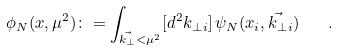Convert formula to latex. <formula><loc_0><loc_0><loc_500><loc_500>\phi _ { N } ( x , \mu ^ { 2 } ) \colon = \int _ { \vec { k _ { \perp } } < \mu ^ { 2 } } [ d ^ { 2 } { k _ { \perp } } _ { i } ] \, \psi _ { N } ( x _ { i } , \vec { k _ { \perp } } _ { i } ) \quad .</formula> 